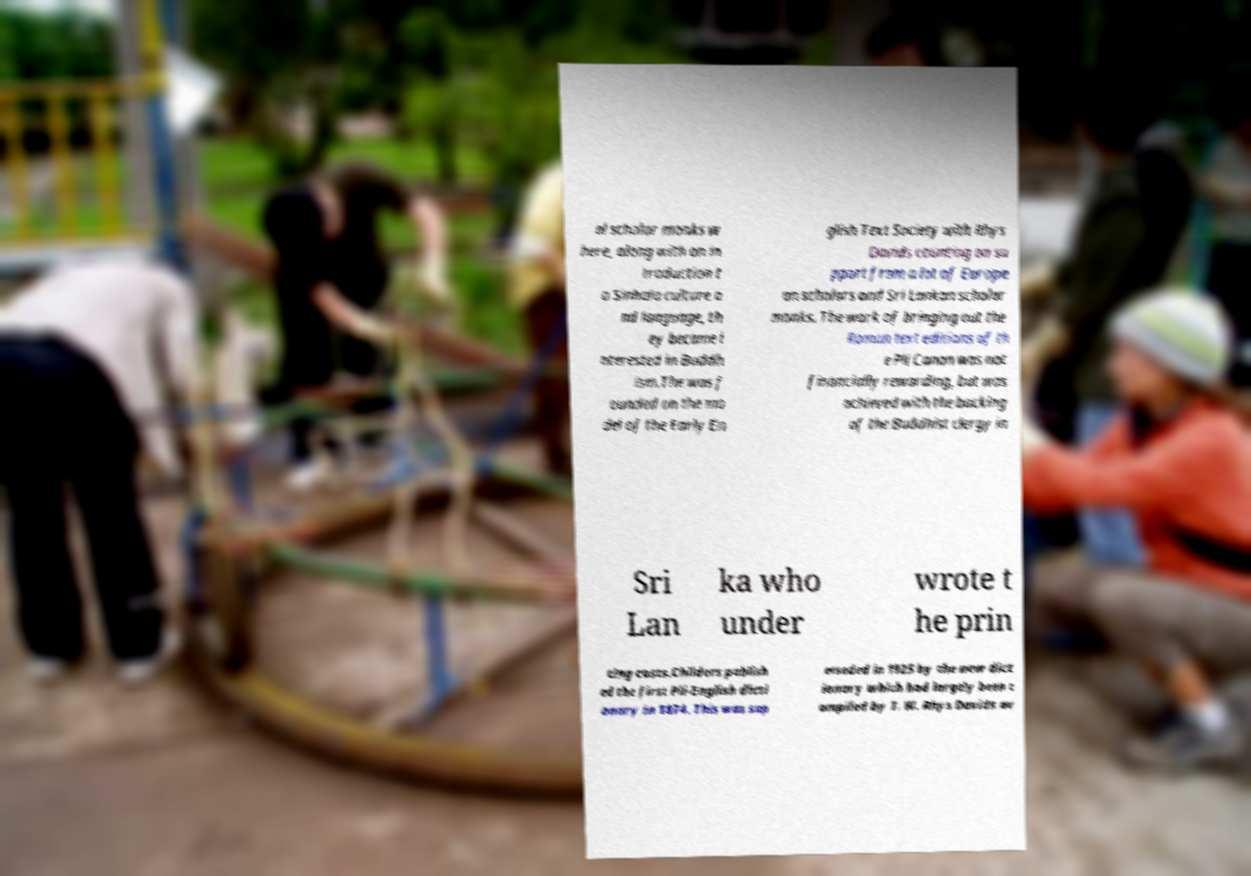Please read and relay the text visible in this image. What does it say? al scholar monks w here, along with an in troduction t o Sinhala culture a nd language, th ey became i nterested in Buddh ism.The was f ounded on the mo del of the Early En glish Text Society with Rhys Davids counting on su pport from a lot of Europe an scholars and Sri Lankan scholar monks. The work of bringing out the Roman text editions of th e Pli Canon was not financially rewarding, but was achieved with the backing of the Buddhist clergy in Sri Lan ka who under wrote t he prin ting costs.Childers publish ed the first Pli-English dicti onary in 1874. This was sup erseded in 1925 by the new dict ionary which had largely been c ompiled by T. W. Rhys Davids ov 